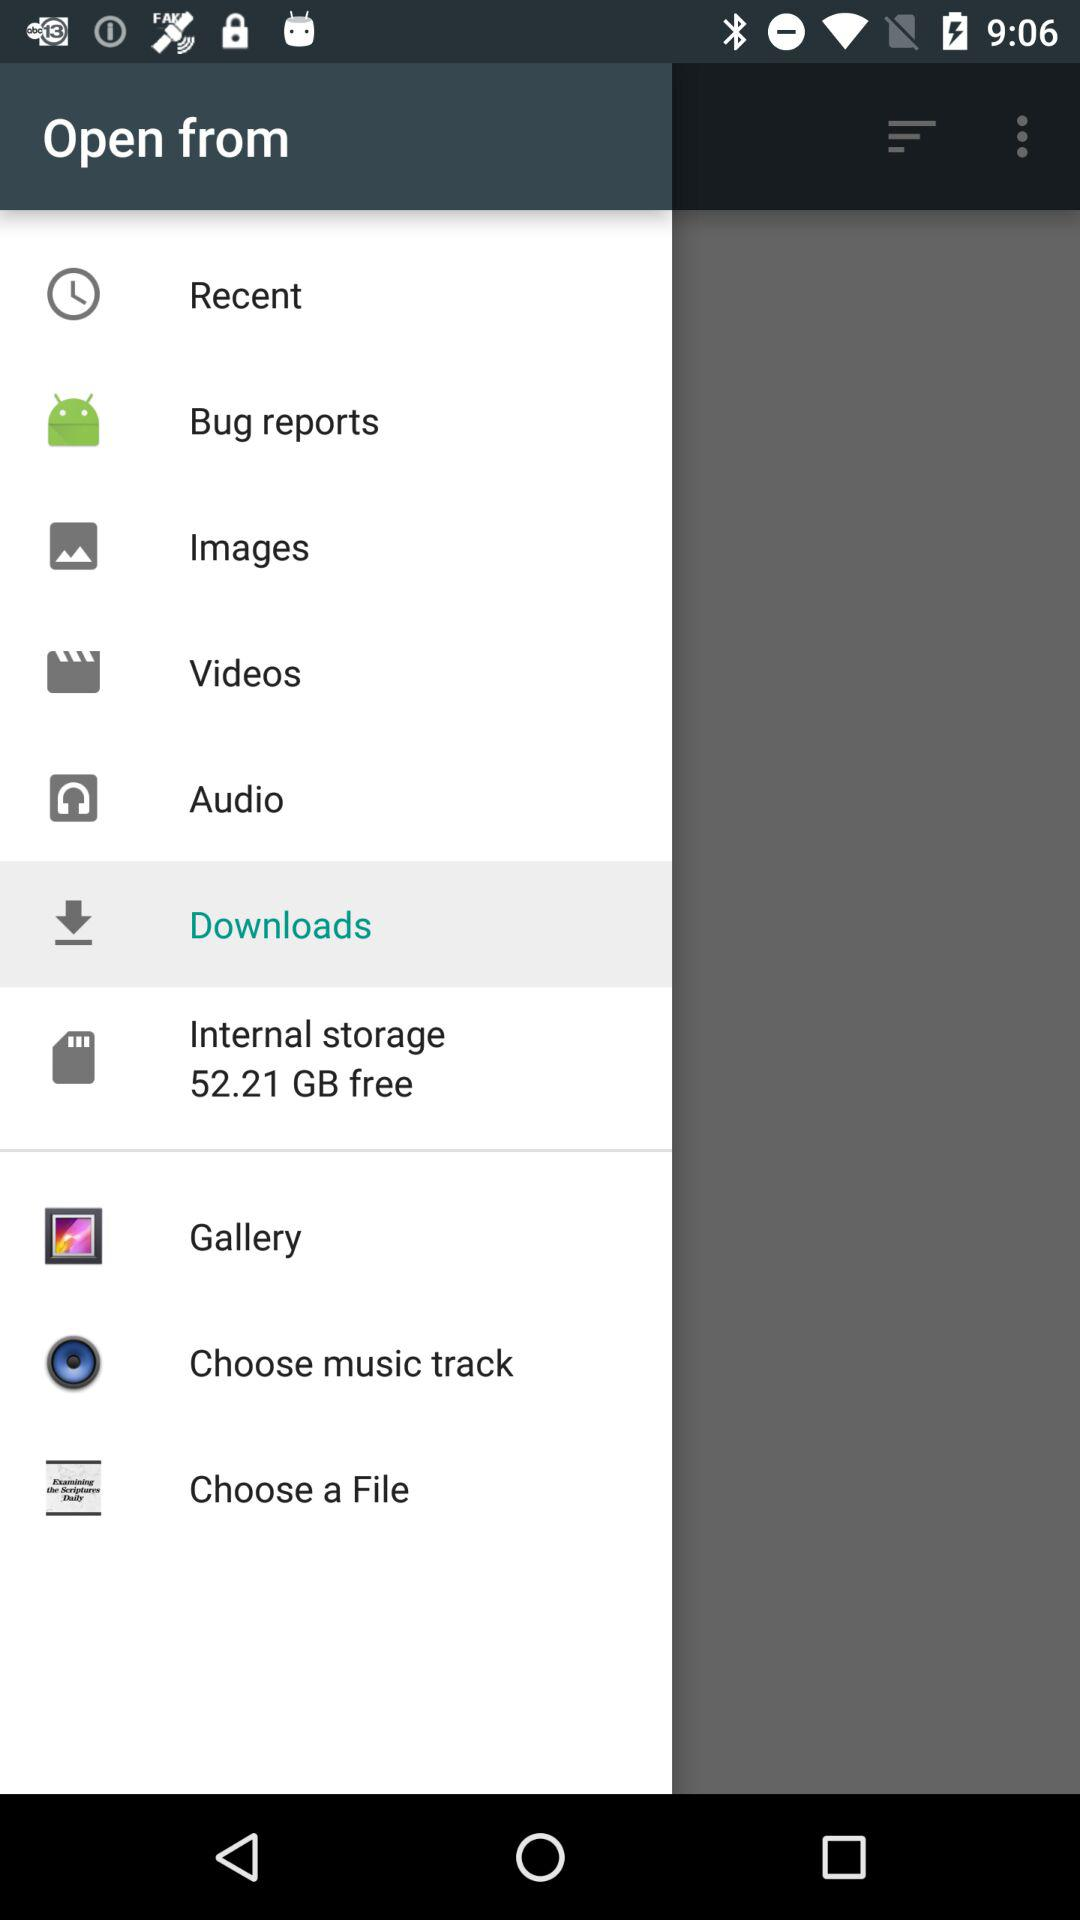What is the size of the internal storage? The free space is 52.21 GB. 